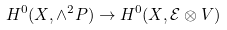<formula> <loc_0><loc_0><loc_500><loc_500>H ^ { 0 } ( X , \wedge ^ { 2 } P ) \to H ^ { 0 } ( X , \mathcal { E } \otimes V )</formula> 